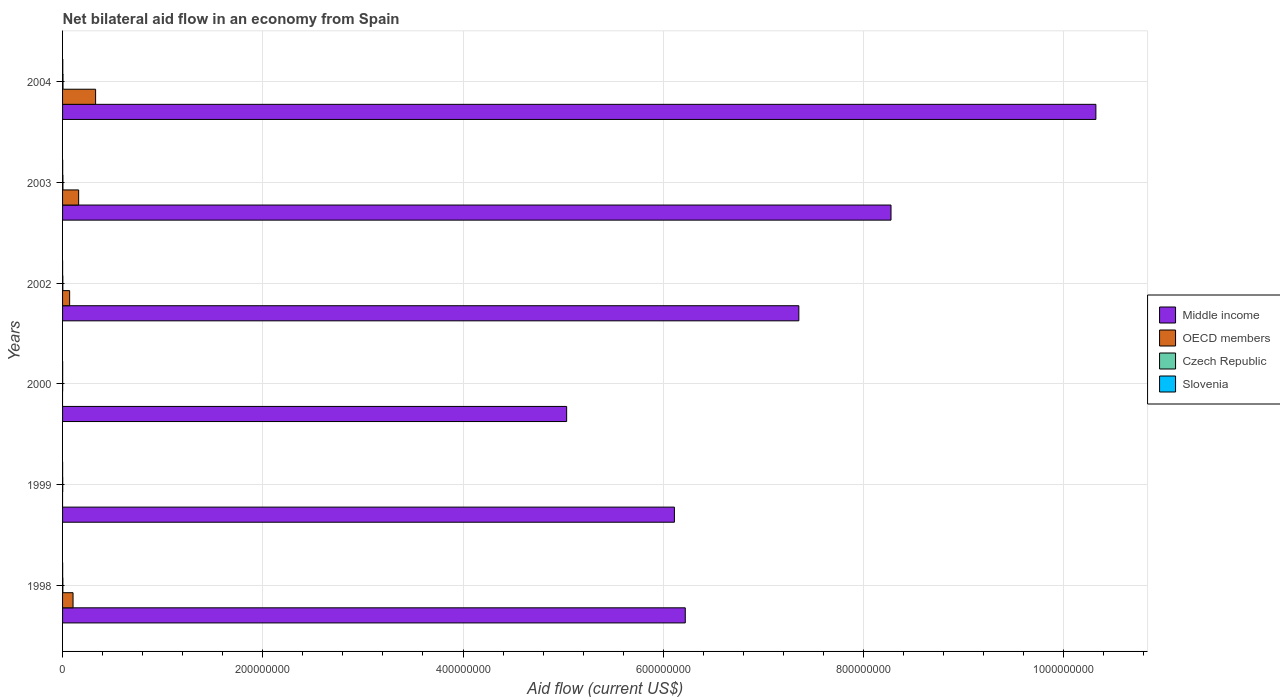How many bars are there on the 2nd tick from the bottom?
Keep it short and to the point. 3. What is the net bilateral aid flow in Czech Republic in 1998?
Keep it short and to the point. 3.00e+05. Across all years, what is the minimum net bilateral aid flow in Slovenia?
Your response must be concise. 3.00e+04. In which year was the net bilateral aid flow in Middle income maximum?
Offer a very short reply. 2004. What is the total net bilateral aid flow in OECD members in the graph?
Give a very brief answer. 6.66e+07. What is the difference between the net bilateral aid flow in Slovenia in 2000 and that in 2002?
Provide a short and direct response. 4.00e+04. What is the difference between the net bilateral aid flow in Middle income in 2004 and the net bilateral aid flow in OECD members in 1998?
Give a very brief answer. 1.02e+09. What is the average net bilateral aid flow in OECD members per year?
Your response must be concise. 1.11e+07. In the year 2004, what is the difference between the net bilateral aid flow in Middle income and net bilateral aid flow in OECD members?
Make the answer very short. 9.99e+08. In how many years, is the net bilateral aid flow in Middle income greater than 200000000 US$?
Provide a short and direct response. 6. What is the ratio of the net bilateral aid flow in Slovenia in 1998 to that in 2000?
Provide a short and direct response. 1.14. Is the net bilateral aid flow in Middle income in 1998 less than that in 2002?
Your response must be concise. Yes. What is the difference between the highest and the second highest net bilateral aid flow in Czech Republic?
Your response must be concise. 8.00e+04. What is the difference between the highest and the lowest net bilateral aid flow in Czech Republic?
Provide a succinct answer. 3.70e+05. In how many years, is the net bilateral aid flow in Czech Republic greater than the average net bilateral aid flow in Czech Republic taken over all years?
Your answer should be very brief. 3. Is the sum of the net bilateral aid flow in OECD members in 1998 and 2002 greater than the maximum net bilateral aid flow in Middle income across all years?
Your response must be concise. No. Is it the case that in every year, the sum of the net bilateral aid flow in Slovenia and net bilateral aid flow in Czech Republic is greater than the sum of net bilateral aid flow in Middle income and net bilateral aid flow in OECD members?
Provide a succinct answer. No. What is the difference between two consecutive major ticks on the X-axis?
Give a very brief answer. 2.00e+08. Are the values on the major ticks of X-axis written in scientific E-notation?
Offer a very short reply. No. Does the graph contain any zero values?
Provide a succinct answer. Yes. Where does the legend appear in the graph?
Your answer should be very brief. Center right. How many legend labels are there?
Your answer should be very brief. 4. How are the legend labels stacked?
Provide a succinct answer. Vertical. What is the title of the graph?
Keep it short and to the point. Net bilateral aid flow in an economy from Spain. What is the label or title of the Y-axis?
Provide a short and direct response. Years. What is the Aid flow (current US$) of Middle income in 1998?
Your answer should be very brief. 6.22e+08. What is the Aid flow (current US$) in OECD members in 1998?
Your answer should be very brief. 1.05e+07. What is the Aid flow (current US$) of Czech Republic in 1998?
Provide a short and direct response. 3.00e+05. What is the Aid flow (current US$) of Middle income in 1999?
Offer a terse response. 6.11e+08. What is the Aid flow (current US$) in Czech Republic in 1999?
Give a very brief answer. 1.50e+05. What is the Aid flow (current US$) in Middle income in 2000?
Your answer should be compact. 5.04e+08. What is the Aid flow (current US$) in Czech Republic in 2000?
Your answer should be very brief. 8.00e+04. What is the Aid flow (current US$) in Slovenia in 2000?
Offer a terse response. 7.00e+04. What is the Aid flow (current US$) of Middle income in 2002?
Provide a short and direct response. 7.35e+08. What is the Aid flow (current US$) in OECD members in 2002?
Give a very brief answer. 7.06e+06. What is the Aid flow (current US$) of Middle income in 2003?
Provide a short and direct response. 8.28e+08. What is the Aid flow (current US$) in OECD members in 2003?
Offer a terse response. 1.61e+07. What is the Aid flow (current US$) in Czech Republic in 2003?
Give a very brief answer. 3.70e+05. What is the Aid flow (current US$) in Middle income in 2004?
Give a very brief answer. 1.03e+09. What is the Aid flow (current US$) in OECD members in 2004?
Offer a very short reply. 3.30e+07. What is the Aid flow (current US$) in Czech Republic in 2004?
Your answer should be very brief. 4.50e+05. Across all years, what is the maximum Aid flow (current US$) of Middle income?
Your answer should be very brief. 1.03e+09. Across all years, what is the maximum Aid flow (current US$) in OECD members?
Your response must be concise. 3.30e+07. Across all years, what is the maximum Aid flow (current US$) of Czech Republic?
Make the answer very short. 4.50e+05. Across all years, what is the maximum Aid flow (current US$) of Slovenia?
Provide a succinct answer. 2.10e+05. Across all years, what is the minimum Aid flow (current US$) in Middle income?
Your answer should be very brief. 5.04e+08. Across all years, what is the minimum Aid flow (current US$) in OECD members?
Provide a short and direct response. 0. Across all years, what is the minimum Aid flow (current US$) of Slovenia?
Keep it short and to the point. 3.00e+04. What is the total Aid flow (current US$) in Middle income in the graph?
Your answer should be compact. 4.33e+09. What is the total Aid flow (current US$) in OECD members in the graph?
Keep it short and to the point. 6.66e+07. What is the total Aid flow (current US$) of Czech Republic in the graph?
Give a very brief answer. 1.62e+06. What is the total Aid flow (current US$) of Slovenia in the graph?
Offer a very short reply. 5.40e+05. What is the difference between the Aid flow (current US$) in Middle income in 1998 and that in 1999?
Your answer should be compact. 1.09e+07. What is the difference between the Aid flow (current US$) of Middle income in 1998 and that in 2000?
Ensure brevity in your answer.  1.18e+08. What is the difference between the Aid flow (current US$) in Czech Republic in 1998 and that in 2000?
Give a very brief answer. 2.20e+05. What is the difference between the Aid flow (current US$) of Middle income in 1998 and that in 2002?
Your response must be concise. -1.13e+08. What is the difference between the Aid flow (current US$) in OECD members in 1998 and that in 2002?
Provide a succinct answer. 3.41e+06. What is the difference between the Aid flow (current US$) of Middle income in 1998 and that in 2003?
Offer a very short reply. -2.06e+08. What is the difference between the Aid flow (current US$) in OECD members in 1998 and that in 2003?
Provide a short and direct response. -5.61e+06. What is the difference between the Aid flow (current US$) in Czech Republic in 1998 and that in 2003?
Your response must be concise. -7.00e+04. What is the difference between the Aid flow (current US$) of Slovenia in 1998 and that in 2003?
Keep it short and to the point. -2.00e+04. What is the difference between the Aid flow (current US$) in Middle income in 1998 and that in 2004?
Your response must be concise. -4.10e+08. What is the difference between the Aid flow (current US$) in OECD members in 1998 and that in 2004?
Your response must be concise. -2.25e+07. What is the difference between the Aid flow (current US$) in Czech Republic in 1998 and that in 2004?
Your answer should be very brief. -1.50e+05. What is the difference between the Aid flow (current US$) of Middle income in 1999 and that in 2000?
Your response must be concise. 1.08e+08. What is the difference between the Aid flow (current US$) in Czech Republic in 1999 and that in 2000?
Provide a short and direct response. 7.00e+04. What is the difference between the Aid flow (current US$) in Slovenia in 1999 and that in 2000?
Offer a terse response. -2.00e+04. What is the difference between the Aid flow (current US$) of Middle income in 1999 and that in 2002?
Make the answer very short. -1.24e+08. What is the difference between the Aid flow (current US$) of Slovenia in 1999 and that in 2002?
Provide a short and direct response. 2.00e+04. What is the difference between the Aid flow (current US$) in Middle income in 1999 and that in 2003?
Provide a succinct answer. -2.16e+08. What is the difference between the Aid flow (current US$) of Czech Republic in 1999 and that in 2003?
Your answer should be very brief. -2.20e+05. What is the difference between the Aid flow (current US$) of Middle income in 1999 and that in 2004?
Provide a succinct answer. -4.21e+08. What is the difference between the Aid flow (current US$) in Czech Republic in 1999 and that in 2004?
Give a very brief answer. -3.00e+05. What is the difference between the Aid flow (current US$) of Slovenia in 1999 and that in 2004?
Ensure brevity in your answer.  -1.60e+05. What is the difference between the Aid flow (current US$) of Middle income in 2000 and that in 2002?
Offer a very short reply. -2.32e+08. What is the difference between the Aid flow (current US$) of Czech Republic in 2000 and that in 2002?
Offer a terse response. -1.90e+05. What is the difference between the Aid flow (current US$) in Slovenia in 2000 and that in 2002?
Make the answer very short. 4.00e+04. What is the difference between the Aid flow (current US$) in Middle income in 2000 and that in 2003?
Keep it short and to the point. -3.24e+08. What is the difference between the Aid flow (current US$) in Czech Republic in 2000 and that in 2003?
Give a very brief answer. -2.90e+05. What is the difference between the Aid flow (current US$) in Slovenia in 2000 and that in 2003?
Your answer should be very brief. -3.00e+04. What is the difference between the Aid flow (current US$) in Middle income in 2000 and that in 2004?
Keep it short and to the point. -5.29e+08. What is the difference between the Aid flow (current US$) of Czech Republic in 2000 and that in 2004?
Make the answer very short. -3.70e+05. What is the difference between the Aid flow (current US$) of Slovenia in 2000 and that in 2004?
Your response must be concise. -1.40e+05. What is the difference between the Aid flow (current US$) in Middle income in 2002 and that in 2003?
Keep it short and to the point. -9.21e+07. What is the difference between the Aid flow (current US$) of OECD members in 2002 and that in 2003?
Your answer should be very brief. -9.02e+06. What is the difference between the Aid flow (current US$) in Middle income in 2002 and that in 2004?
Give a very brief answer. -2.97e+08. What is the difference between the Aid flow (current US$) in OECD members in 2002 and that in 2004?
Provide a short and direct response. -2.59e+07. What is the difference between the Aid flow (current US$) of Middle income in 2003 and that in 2004?
Offer a very short reply. -2.05e+08. What is the difference between the Aid flow (current US$) in OECD members in 2003 and that in 2004?
Offer a terse response. -1.69e+07. What is the difference between the Aid flow (current US$) of Slovenia in 2003 and that in 2004?
Ensure brevity in your answer.  -1.10e+05. What is the difference between the Aid flow (current US$) of Middle income in 1998 and the Aid flow (current US$) of Czech Republic in 1999?
Keep it short and to the point. 6.22e+08. What is the difference between the Aid flow (current US$) of Middle income in 1998 and the Aid flow (current US$) of Slovenia in 1999?
Your answer should be very brief. 6.22e+08. What is the difference between the Aid flow (current US$) in OECD members in 1998 and the Aid flow (current US$) in Czech Republic in 1999?
Provide a short and direct response. 1.03e+07. What is the difference between the Aid flow (current US$) of OECD members in 1998 and the Aid flow (current US$) of Slovenia in 1999?
Keep it short and to the point. 1.04e+07. What is the difference between the Aid flow (current US$) of Czech Republic in 1998 and the Aid flow (current US$) of Slovenia in 1999?
Keep it short and to the point. 2.50e+05. What is the difference between the Aid flow (current US$) in Middle income in 1998 and the Aid flow (current US$) in Czech Republic in 2000?
Keep it short and to the point. 6.22e+08. What is the difference between the Aid flow (current US$) of Middle income in 1998 and the Aid flow (current US$) of Slovenia in 2000?
Provide a short and direct response. 6.22e+08. What is the difference between the Aid flow (current US$) in OECD members in 1998 and the Aid flow (current US$) in Czech Republic in 2000?
Offer a terse response. 1.04e+07. What is the difference between the Aid flow (current US$) of OECD members in 1998 and the Aid flow (current US$) of Slovenia in 2000?
Your answer should be very brief. 1.04e+07. What is the difference between the Aid flow (current US$) in Middle income in 1998 and the Aid flow (current US$) in OECD members in 2002?
Your response must be concise. 6.15e+08. What is the difference between the Aid flow (current US$) in Middle income in 1998 and the Aid flow (current US$) in Czech Republic in 2002?
Provide a succinct answer. 6.22e+08. What is the difference between the Aid flow (current US$) of Middle income in 1998 and the Aid flow (current US$) of Slovenia in 2002?
Your answer should be compact. 6.22e+08. What is the difference between the Aid flow (current US$) of OECD members in 1998 and the Aid flow (current US$) of Czech Republic in 2002?
Your answer should be very brief. 1.02e+07. What is the difference between the Aid flow (current US$) in OECD members in 1998 and the Aid flow (current US$) in Slovenia in 2002?
Make the answer very short. 1.04e+07. What is the difference between the Aid flow (current US$) of Middle income in 1998 and the Aid flow (current US$) of OECD members in 2003?
Keep it short and to the point. 6.06e+08. What is the difference between the Aid flow (current US$) of Middle income in 1998 and the Aid flow (current US$) of Czech Republic in 2003?
Offer a very short reply. 6.22e+08. What is the difference between the Aid flow (current US$) in Middle income in 1998 and the Aid flow (current US$) in Slovenia in 2003?
Provide a short and direct response. 6.22e+08. What is the difference between the Aid flow (current US$) in OECD members in 1998 and the Aid flow (current US$) in Czech Republic in 2003?
Give a very brief answer. 1.01e+07. What is the difference between the Aid flow (current US$) in OECD members in 1998 and the Aid flow (current US$) in Slovenia in 2003?
Offer a very short reply. 1.04e+07. What is the difference between the Aid flow (current US$) of Czech Republic in 1998 and the Aid flow (current US$) of Slovenia in 2003?
Your answer should be very brief. 2.00e+05. What is the difference between the Aid flow (current US$) in Middle income in 1998 and the Aid flow (current US$) in OECD members in 2004?
Keep it short and to the point. 5.89e+08. What is the difference between the Aid flow (current US$) of Middle income in 1998 and the Aid flow (current US$) of Czech Republic in 2004?
Offer a terse response. 6.22e+08. What is the difference between the Aid flow (current US$) of Middle income in 1998 and the Aid flow (current US$) of Slovenia in 2004?
Offer a terse response. 6.22e+08. What is the difference between the Aid flow (current US$) of OECD members in 1998 and the Aid flow (current US$) of Czech Republic in 2004?
Provide a short and direct response. 1.00e+07. What is the difference between the Aid flow (current US$) in OECD members in 1998 and the Aid flow (current US$) in Slovenia in 2004?
Make the answer very short. 1.03e+07. What is the difference between the Aid flow (current US$) of Czech Republic in 1998 and the Aid flow (current US$) of Slovenia in 2004?
Keep it short and to the point. 9.00e+04. What is the difference between the Aid flow (current US$) of Middle income in 1999 and the Aid flow (current US$) of Czech Republic in 2000?
Your response must be concise. 6.11e+08. What is the difference between the Aid flow (current US$) in Middle income in 1999 and the Aid flow (current US$) in Slovenia in 2000?
Offer a very short reply. 6.11e+08. What is the difference between the Aid flow (current US$) of Czech Republic in 1999 and the Aid flow (current US$) of Slovenia in 2000?
Give a very brief answer. 8.00e+04. What is the difference between the Aid flow (current US$) of Middle income in 1999 and the Aid flow (current US$) of OECD members in 2002?
Offer a very short reply. 6.04e+08. What is the difference between the Aid flow (current US$) in Middle income in 1999 and the Aid flow (current US$) in Czech Republic in 2002?
Give a very brief answer. 6.11e+08. What is the difference between the Aid flow (current US$) of Middle income in 1999 and the Aid flow (current US$) of Slovenia in 2002?
Ensure brevity in your answer.  6.11e+08. What is the difference between the Aid flow (current US$) in Czech Republic in 1999 and the Aid flow (current US$) in Slovenia in 2002?
Provide a short and direct response. 1.20e+05. What is the difference between the Aid flow (current US$) of Middle income in 1999 and the Aid flow (current US$) of OECD members in 2003?
Your answer should be very brief. 5.95e+08. What is the difference between the Aid flow (current US$) in Middle income in 1999 and the Aid flow (current US$) in Czech Republic in 2003?
Offer a very short reply. 6.11e+08. What is the difference between the Aid flow (current US$) of Middle income in 1999 and the Aid flow (current US$) of Slovenia in 2003?
Make the answer very short. 6.11e+08. What is the difference between the Aid flow (current US$) in Middle income in 1999 and the Aid flow (current US$) in OECD members in 2004?
Provide a succinct answer. 5.78e+08. What is the difference between the Aid flow (current US$) in Middle income in 1999 and the Aid flow (current US$) in Czech Republic in 2004?
Offer a very short reply. 6.11e+08. What is the difference between the Aid flow (current US$) of Middle income in 1999 and the Aid flow (current US$) of Slovenia in 2004?
Offer a very short reply. 6.11e+08. What is the difference between the Aid flow (current US$) in Czech Republic in 1999 and the Aid flow (current US$) in Slovenia in 2004?
Your answer should be very brief. -6.00e+04. What is the difference between the Aid flow (current US$) in Middle income in 2000 and the Aid flow (current US$) in OECD members in 2002?
Ensure brevity in your answer.  4.96e+08. What is the difference between the Aid flow (current US$) of Middle income in 2000 and the Aid flow (current US$) of Czech Republic in 2002?
Make the answer very short. 5.03e+08. What is the difference between the Aid flow (current US$) in Middle income in 2000 and the Aid flow (current US$) in Slovenia in 2002?
Make the answer very short. 5.03e+08. What is the difference between the Aid flow (current US$) of Middle income in 2000 and the Aid flow (current US$) of OECD members in 2003?
Provide a succinct answer. 4.87e+08. What is the difference between the Aid flow (current US$) of Middle income in 2000 and the Aid flow (current US$) of Czech Republic in 2003?
Make the answer very short. 5.03e+08. What is the difference between the Aid flow (current US$) of Middle income in 2000 and the Aid flow (current US$) of Slovenia in 2003?
Make the answer very short. 5.03e+08. What is the difference between the Aid flow (current US$) in Middle income in 2000 and the Aid flow (current US$) in OECD members in 2004?
Give a very brief answer. 4.71e+08. What is the difference between the Aid flow (current US$) in Middle income in 2000 and the Aid flow (current US$) in Czech Republic in 2004?
Your answer should be compact. 5.03e+08. What is the difference between the Aid flow (current US$) of Middle income in 2000 and the Aid flow (current US$) of Slovenia in 2004?
Provide a short and direct response. 5.03e+08. What is the difference between the Aid flow (current US$) of Middle income in 2002 and the Aid flow (current US$) of OECD members in 2003?
Keep it short and to the point. 7.19e+08. What is the difference between the Aid flow (current US$) of Middle income in 2002 and the Aid flow (current US$) of Czech Republic in 2003?
Ensure brevity in your answer.  7.35e+08. What is the difference between the Aid flow (current US$) in Middle income in 2002 and the Aid flow (current US$) in Slovenia in 2003?
Offer a terse response. 7.35e+08. What is the difference between the Aid flow (current US$) in OECD members in 2002 and the Aid flow (current US$) in Czech Republic in 2003?
Offer a very short reply. 6.69e+06. What is the difference between the Aid flow (current US$) of OECD members in 2002 and the Aid flow (current US$) of Slovenia in 2003?
Your answer should be compact. 6.96e+06. What is the difference between the Aid flow (current US$) in Middle income in 2002 and the Aid flow (current US$) in OECD members in 2004?
Your answer should be very brief. 7.02e+08. What is the difference between the Aid flow (current US$) in Middle income in 2002 and the Aid flow (current US$) in Czech Republic in 2004?
Provide a succinct answer. 7.35e+08. What is the difference between the Aid flow (current US$) in Middle income in 2002 and the Aid flow (current US$) in Slovenia in 2004?
Give a very brief answer. 7.35e+08. What is the difference between the Aid flow (current US$) in OECD members in 2002 and the Aid flow (current US$) in Czech Republic in 2004?
Make the answer very short. 6.61e+06. What is the difference between the Aid flow (current US$) of OECD members in 2002 and the Aid flow (current US$) of Slovenia in 2004?
Provide a short and direct response. 6.85e+06. What is the difference between the Aid flow (current US$) of Czech Republic in 2002 and the Aid flow (current US$) of Slovenia in 2004?
Make the answer very short. 6.00e+04. What is the difference between the Aid flow (current US$) in Middle income in 2003 and the Aid flow (current US$) in OECD members in 2004?
Give a very brief answer. 7.95e+08. What is the difference between the Aid flow (current US$) in Middle income in 2003 and the Aid flow (current US$) in Czech Republic in 2004?
Give a very brief answer. 8.27e+08. What is the difference between the Aid flow (current US$) in Middle income in 2003 and the Aid flow (current US$) in Slovenia in 2004?
Your answer should be very brief. 8.27e+08. What is the difference between the Aid flow (current US$) of OECD members in 2003 and the Aid flow (current US$) of Czech Republic in 2004?
Offer a very short reply. 1.56e+07. What is the difference between the Aid flow (current US$) in OECD members in 2003 and the Aid flow (current US$) in Slovenia in 2004?
Keep it short and to the point. 1.59e+07. What is the average Aid flow (current US$) in Middle income per year?
Offer a very short reply. 7.22e+08. What is the average Aid flow (current US$) of OECD members per year?
Keep it short and to the point. 1.11e+07. What is the average Aid flow (current US$) of Slovenia per year?
Provide a succinct answer. 9.00e+04. In the year 1998, what is the difference between the Aid flow (current US$) in Middle income and Aid flow (current US$) in OECD members?
Provide a succinct answer. 6.12e+08. In the year 1998, what is the difference between the Aid flow (current US$) in Middle income and Aid flow (current US$) in Czech Republic?
Give a very brief answer. 6.22e+08. In the year 1998, what is the difference between the Aid flow (current US$) of Middle income and Aid flow (current US$) of Slovenia?
Ensure brevity in your answer.  6.22e+08. In the year 1998, what is the difference between the Aid flow (current US$) in OECD members and Aid flow (current US$) in Czech Republic?
Offer a terse response. 1.02e+07. In the year 1998, what is the difference between the Aid flow (current US$) in OECD members and Aid flow (current US$) in Slovenia?
Ensure brevity in your answer.  1.04e+07. In the year 1998, what is the difference between the Aid flow (current US$) in Czech Republic and Aid flow (current US$) in Slovenia?
Your answer should be very brief. 2.20e+05. In the year 1999, what is the difference between the Aid flow (current US$) in Middle income and Aid flow (current US$) in Czech Republic?
Give a very brief answer. 6.11e+08. In the year 1999, what is the difference between the Aid flow (current US$) in Middle income and Aid flow (current US$) in Slovenia?
Make the answer very short. 6.11e+08. In the year 2000, what is the difference between the Aid flow (current US$) in Middle income and Aid flow (current US$) in Czech Republic?
Offer a terse response. 5.03e+08. In the year 2000, what is the difference between the Aid flow (current US$) in Middle income and Aid flow (current US$) in Slovenia?
Your response must be concise. 5.03e+08. In the year 2000, what is the difference between the Aid flow (current US$) in Czech Republic and Aid flow (current US$) in Slovenia?
Provide a succinct answer. 10000. In the year 2002, what is the difference between the Aid flow (current US$) of Middle income and Aid flow (current US$) of OECD members?
Your response must be concise. 7.28e+08. In the year 2002, what is the difference between the Aid flow (current US$) of Middle income and Aid flow (current US$) of Czech Republic?
Keep it short and to the point. 7.35e+08. In the year 2002, what is the difference between the Aid flow (current US$) in Middle income and Aid flow (current US$) in Slovenia?
Give a very brief answer. 7.35e+08. In the year 2002, what is the difference between the Aid flow (current US$) of OECD members and Aid flow (current US$) of Czech Republic?
Provide a succinct answer. 6.79e+06. In the year 2002, what is the difference between the Aid flow (current US$) in OECD members and Aid flow (current US$) in Slovenia?
Your answer should be compact. 7.03e+06. In the year 2002, what is the difference between the Aid flow (current US$) in Czech Republic and Aid flow (current US$) in Slovenia?
Make the answer very short. 2.40e+05. In the year 2003, what is the difference between the Aid flow (current US$) in Middle income and Aid flow (current US$) in OECD members?
Your response must be concise. 8.11e+08. In the year 2003, what is the difference between the Aid flow (current US$) in Middle income and Aid flow (current US$) in Czech Republic?
Keep it short and to the point. 8.27e+08. In the year 2003, what is the difference between the Aid flow (current US$) in Middle income and Aid flow (current US$) in Slovenia?
Provide a short and direct response. 8.27e+08. In the year 2003, what is the difference between the Aid flow (current US$) of OECD members and Aid flow (current US$) of Czech Republic?
Your response must be concise. 1.57e+07. In the year 2003, what is the difference between the Aid flow (current US$) in OECD members and Aid flow (current US$) in Slovenia?
Make the answer very short. 1.60e+07. In the year 2004, what is the difference between the Aid flow (current US$) of Middle income and Aid flow (current US$) of OECD members?
Ensure brevity in your answer.  9.99e+08. In the year 2004, what is the difference between the Aid flow (current US$) in Middle income and Aid flow (current US$) in Czech Republic?
Provide a short and direct response. 1.03e+09. In the year 2004, what is the difference between the Aid flow (current US$) of Middle income and Aid flow (current US$) of Slovenia?
Your answer should be very brief. 1.03e+09. In the year 2004, what is the difference between the Aid flow (current US$) in OECD members and Aid flow (current US$) in Czech Republic?
Offer a very short reply. 3.26e+07. In the year 2004, what is the difference between the Aid flow (current US$) in OECD members and Aid flow (current US$) in Slovenia?
Your response must be concise. 3.28e+07. What is the ratio of the Aid flow (current US$) in Middle income in 1998 to that in 1999?
Ensure brevity in your answer.  1.02. What is the ratio of the Aid flow (current US$) in Slovenia in 1998 to that in 1999?
Provide a succinct answer. 1.6. What is the ratio of the Aid flow (current US$) of Middle income in 1998 to that in 2000?
Keep it short and to the point. 1.24. What is the ratio of the Aid flow (current US$) in Czech Republic in 1998 to that in 2000?
Provide a succinct answer. 3.75. What is the ratio of the Aid flow (current US$) of Middle income in 1998 to that in 2002?
Give a very brief answer. 0.85. What is the ratio of the Aid flow (current US$) in OECD members in 1998 to that in 2002?
Ensure brevity in your answer.  1.48. What is the ratio of the Aid flow (current US$) in Slovenia in 1998 to that in 2002?
Offer a very short reply. 2.67. What is the ratio of the Aid flow (current US$) of Middle income in 1998 to that in 2003?
Provide a short and direct response. 0.75. What is the ratio of the Aid flow (current US$) of OECD members in 1998 to that in 2003?
Provide a short and direct response. 0.65. What is the ratio of the Aid flow (current US$) in Czech Republic in 1998 to that in 2003?
Offer a very short reply. 0.81. What is the ratio of the Aid flow (current US$) of Middle income in 1998 to that in 2004?
Provide a short and direct response. 0.6. What is the ratio of the Aid flow (current US$) in OECD members in 1998 to that in 2004?
Make the answer very short. 0.32. What is the ratio of the Aid flow (current US$) in Czech Republic in 1998 to that in 2004?
Your response must be concise. 0.67. What is the ratio of the Aid flow (current US$) in Slovenia in 1998 to that in 2004?
Provide a succinct answer. 0.38. What is the ratio of the Aid flow (current US$) in Middle income in 1999 to that in 2000?
Make the answer very short. 1.21. What is the ratio of the Aid flow (current US$) of Czech Republic in 1999 to that in 2000?
Ensure brevity in your answer.  1.88. What is the ratio of the Aid flow (current US$) in Slovenia in 1999 to that in 2000?
Offer a terse response. 0.71. What is the ratio of the Aid flow (current US$) in Middle income in 1999 to that in 2002?
Your response must be concise. 0.83. What is the ratio of the Aid flow (current US$) of Czech Republic in 1999 to that in 2002?
Provide a short and direct response. 0.56. What is the ratio of the Aid flow (current US$) in Middle income in 1999 to that in 2003?
Offer a terse response. 0.74. What is the ratio of the Aid flow (current US$) of Czech Republic in 1999 to that in 2003?
Ensure brevity in your answer.  0.41. What is the ratio of the Aid flow (current US$) of Slovenia in 1999 to that in 2003?
Keep it short and to the point. 0.5. What is the ratio of the Aid flow (current US$) in Middle income in 1999 to that in 2004?
Keep it short and to the point. 0.59. What is the ratio of the Aid flow (current US$) in Slovenia in 1999 to that in 2004?
Make the answer very short. 0.24. What is the ratio of the Aid flow (current US$) of Middle income in 2000 to that in 2002?
Keep it short and to the point. 0.68. What is the ratio of the Aid flow (current US$) in Czech Republic in 2000 to that in 2002?
Offer a very short reply. 0.3. What is the ratio of the Aid flow (current US$) in Slovenia in 2000 to that in 2002?
Make the answer very short. 2.33. What is the ratio of the Aid flow (current US$) of Middle income in 2000 to that in 2003?
Provide a succinct answer. 0.61. What is the ratio of the Aid flow (current US$) in Czech Republic in 2000 to that in 2003?
Offer a terse response. 0.22. What is the ratio of the Aid flow (current US$) of Middle income in 2000 to that in 2004?
Provide a short and direct response. 0.49. What is the ratio of the Aid flow (current US$) in Czech Republic in 2000 to that in 2004?
Your answer should be compact. 0.18. What is the ratio of the Aid flow (current US$) of Slovenia in 2000 to that in 2004?
Your response must be concise. 0.33. What is the ratio of the Aid flow (current US$) in Middle income in 2002 to that in 2003?
Your answer should be very brief. 0.89. What is the ratio of the Aid flow (current US$) in OECD members in 2002 to that in 2003?
Offer a very short reply. 0.44. What is the ratio of the Aid flow (current US$) of Czech Republic in 2002 to that in 2003?
Provide a short and direct response. 0.73. What is the ratio of the Aid flow (current US$) of Slovenia in 2002 to that in 2003?
Give a very brief answer. 0.3. What is the ratio of the Aid flow (current US$) of Middle income in 2002 to that in 2004?
Offer a terse response. 0.71. What is the ratio of the Aid flow (current US$) in OECD members in 2002 to that in 2004?
Offer a very short reply. 0.21. What is the ratio of the Aid flow (current US$) in Slovenia in 2002 to that in 2004?
Offer a very short reply. 0.14. What is the ratio of the Aid flow (current US$) of Middle income in 2003 to that in 2004?
Provide a succinct answer. 0.8. What is the ratio of the Aid flow (current US$) in OECD members in 2003 to that in 2004?
Provide a succinct answer. 0.49. What is the ratio of the Aid flow (current US$) of Czech Republic in 2003 to that in 2004?
Provide a short and direct response. 0.82. What is the ratio of the Aid flow (current US$) of Slovenia in 2003 to that in 2004?
Your response must be concise. 0.48. What is the difference between the highest and the second highest Aid flow (current US$) in Middle income?
Make the answer very short. 2.05e+08. What is the difference between the highest and the second highest Aid flow (current US$) in OECD members?
Your answer should be compact. 1.69e+07. What is the difference between the highest and the second highest Aid flow (current US$) of Slovenia?
Offer a very short reply. 1.10e+05. What is the difference between the highest and the lowest Aid flow (current US$) in Middle income?
Offer a very short reply. 5.29e+08. What is the difference between the highest and the lowest Aid flow (current US$) of OECD members?
Your answer should be very brief. 3.30e+07. What is the difference between the highest and the lowest Aid flow (current US$) of Czech Republic?
Offer a very short reply. 3.70e+05. 